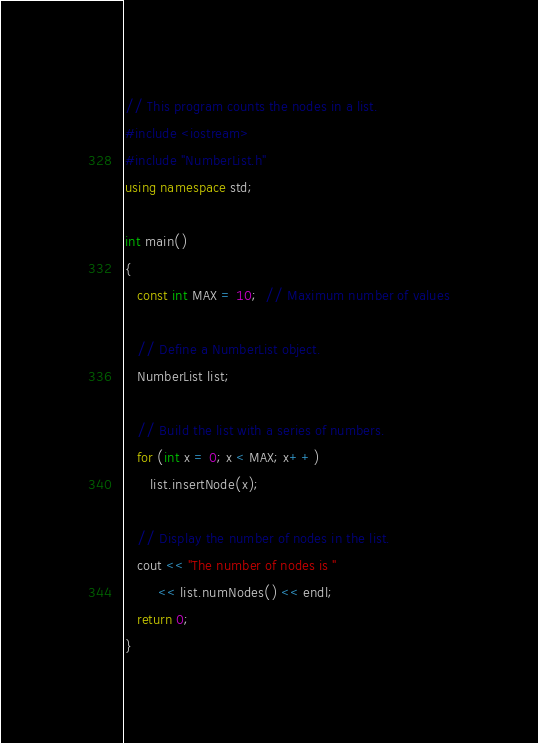<code> <loc_0><loc_0><loc_500><loc_500><_C++_>// This program counts the nodes in a list.
#include <iostream>
#include "NumberList.h"
using namespace std;

int main()
{
   const int MAX = 10;  // Maximum number of values

   // Define a NumberList object.
   NumberList list;

   // Build the list with a series of numbers.
   for (int x = 0; x < MAX; x++)
      list.insertNode(x);

   // Display the number of nodes in the list.
   cout << "The number of nodes is "
        << list.numNodes() << endl;
   return 0;
}</code> 